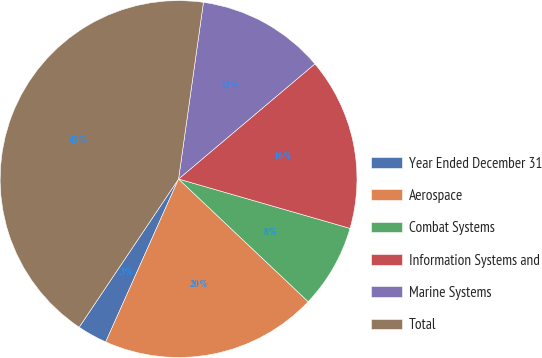<chart> <loc_0><loc_0><loc_500><loc_500><pie_chart><fcel>Year Ended December 31<fcel>Aerospace<fcel>Combat Systems<fcel>Information Systems and<fcel>Marine Systems<fcel>Total<nl><fcel>2.71%<fcel>19.63%<fcel>7.6%<fcel>15.62%<fcel>11.61%<fcel>42.82%<nl></chart> 